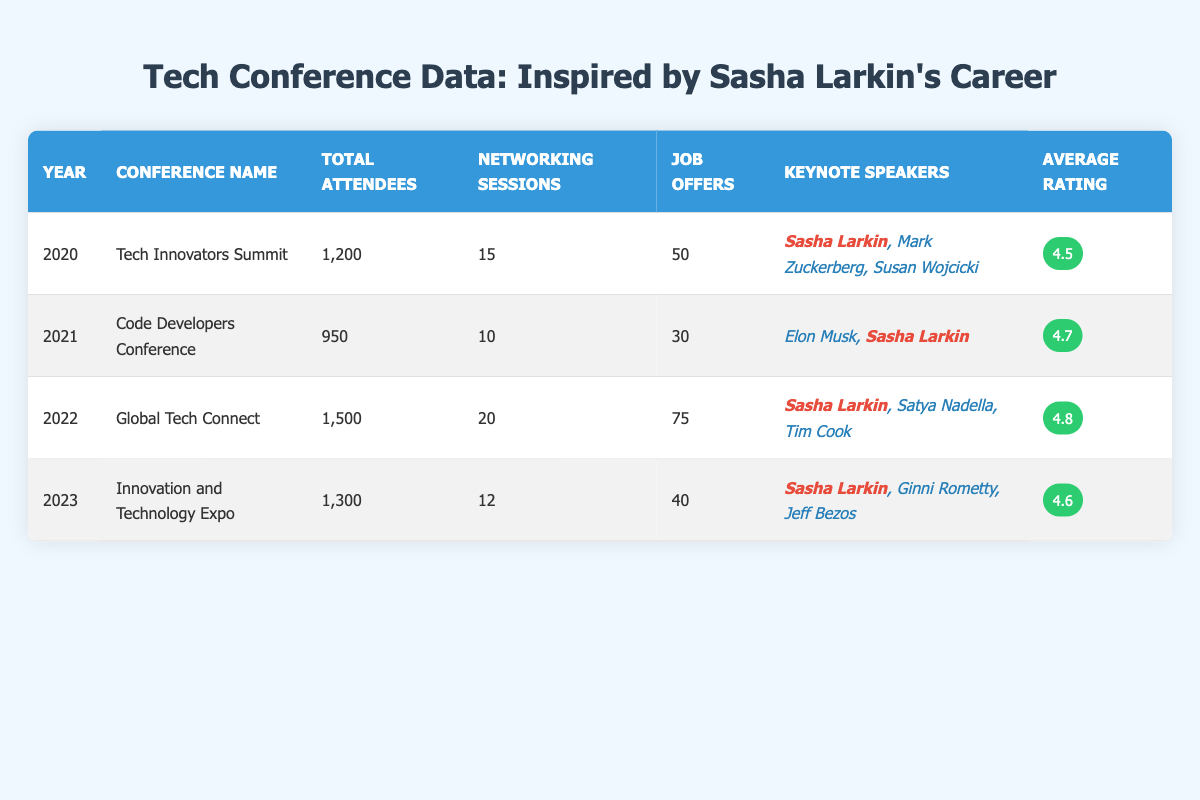What was the total number of job offers at the 2022 conference? According to the table, the job offers for the Global Tech Connect conference held in 2022 is listed as 75.
Answer: 75 Which conference had the highest average attendee rating? By comparing the average ratings in the table, 2022's Global Tech Connect has the highest rating of 4.8.
Answer: Global Tech Connect in 2022 How many networking sessions took place in total across all conferences? I will add the networking sessions from each year: 15 (2020) + 10 (2021) + 20 (2022) + 12 (2023) = 57.
Answer: 57 Was Sasha Larkin a keynote speaker at the 2021 conference? The table shows that she was one of the keynote speakers at the Code Developers Conference in 2021.
Answer: Yes What was the change in total attendees from 2020 to 2023? The total attendees in 2020 was 1200, and in 2023 it was 1300. The change is calculated as 1300 - 1200 = 100.
Answer: 100 Which year had the fewest total attendees, and how many were there? Looking at the total attendees in the table, 2021 had the fewest with 950.
Answer: 2021 had 950 attendees Calculate the average number of job offers per conference over the four years. The total number of job offers is 50 (2020) + 30 (2021) + 75 (2022) + 40 (2023) = 195. Then, divide by 4 (the number of conferences): 195 / 4 = 48.75.
Answer: 48.75 If the average rating of the 2023 conference increased by 0.1, what would it be? The average rating for the 2023 conference is currently listed as 4.6. Adding 0.1 gives 4.6 + 0.1 = 4.7.
Answer: 4.7 In how many conferences did Sasha Larkin participate as a keynote speaker? By checking the table, she was a keynote speaker in 2020, 2021, 2022, and 2023, making it a total of 4 conferences.
Answer: 4 What was the average number of total attendees across all the years? The total attendees are 1200 (2020) + 950 (2021) + 1500 (2022) + 1300 (2023) = 3950. Dividing by 4 gives: 3950 / 4 = 987.5.
Answer: 987.5 